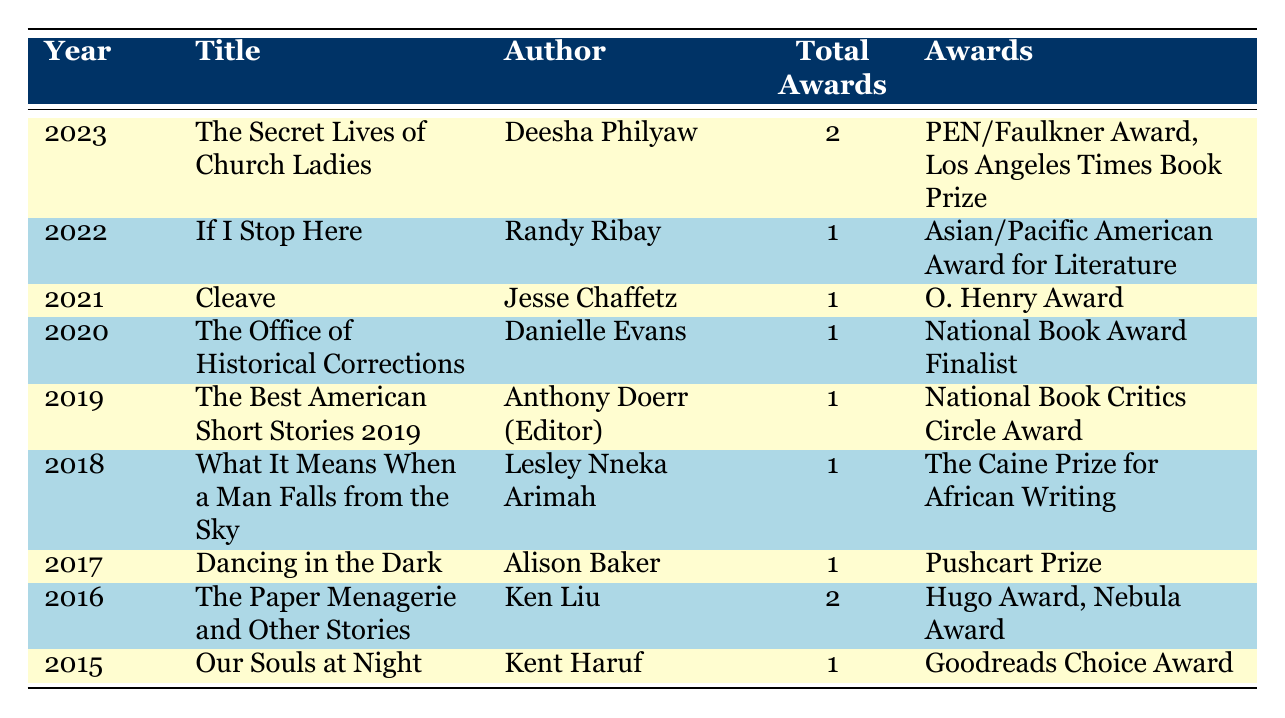What is the title of the award-winning short story collection published in 2023? The table shows the data chronologically, where the row for the year 2023 lists "The Secret Lives of Church Ladies" as the title of the award-winning short story collection for that year.
Answer: The Secret Lives of Church Ladies How many awards did "The Paper Menagerie and Other Stories" win? Referring to the row of the year 2016, the total awards column indicates that "The Paper Menagerie and Other Stories" won 2 awards.
Answer: 2 Was "If I Stop Here" awarded multiple different awards? Looking at the row for the year 2022, "If I Stop Here" is acknowledged for winning only one award, which is the Asian/Pacific American Award for Literature, thus it did not win multiple awards.
Answer: No Which author has the most awards among the listed short story collections? Analyzing the table, we see that both 2023 and 2016 have titles with 2 awards each: "The Secret Lives of Church Ladies" by Deesha Philyaw and "The Paper Menagerie and Other Stories" by Ken Liu. Therefore, these two authors share the distinction of having the most awards.
Answer: Deesha Philyaw and Ken Liu What is the total number of awards won by short story collections from 2015 to 2023? To find the total, we add the total awards for each year: 2 (2023) + 1 (2022) + 1 (2021) + 1 (2020) + 1 (2019) + 1 (2018) + 1 (2017) + 2 (2016) + 1 (2015) = 11 awards.
Answer: 11 Did "Dancing in the Dark" win an award in the same year as "Our Souls at Night"? Looking closely, "Dancing in the Dark" was awarded in 2017, while "Our Souls at Night" was recognized in 2015. The two titles do not belong to the same year, confirming that they did not win awards together.
Answer: No What percentage of the awards won by short story collections in this analysis are greater than or equal to 2? Award counts of 2 are from "The Secret Lives of Church Ladies" and "The Paper Menagerie and Other Stories" out of a total of 11 awards. The count of those with 2 or more awards is 2, hence, the percentage is (2/11) * 100%, which equals approximately 18.18%.
Answer: 18.18% Which genre received recognition for winning the most total awards in the data? The only genres listed in the table under analysis for total awards are "Short Story Collection" and "Anthology." However, since "The Best American Short Stories 2019" is an anthology and won 1 award, while the short story collections have won a total of 10 awards, it can be concluded that "Short Story Collection" has won the most overall.
Answer: Short Story Collection 